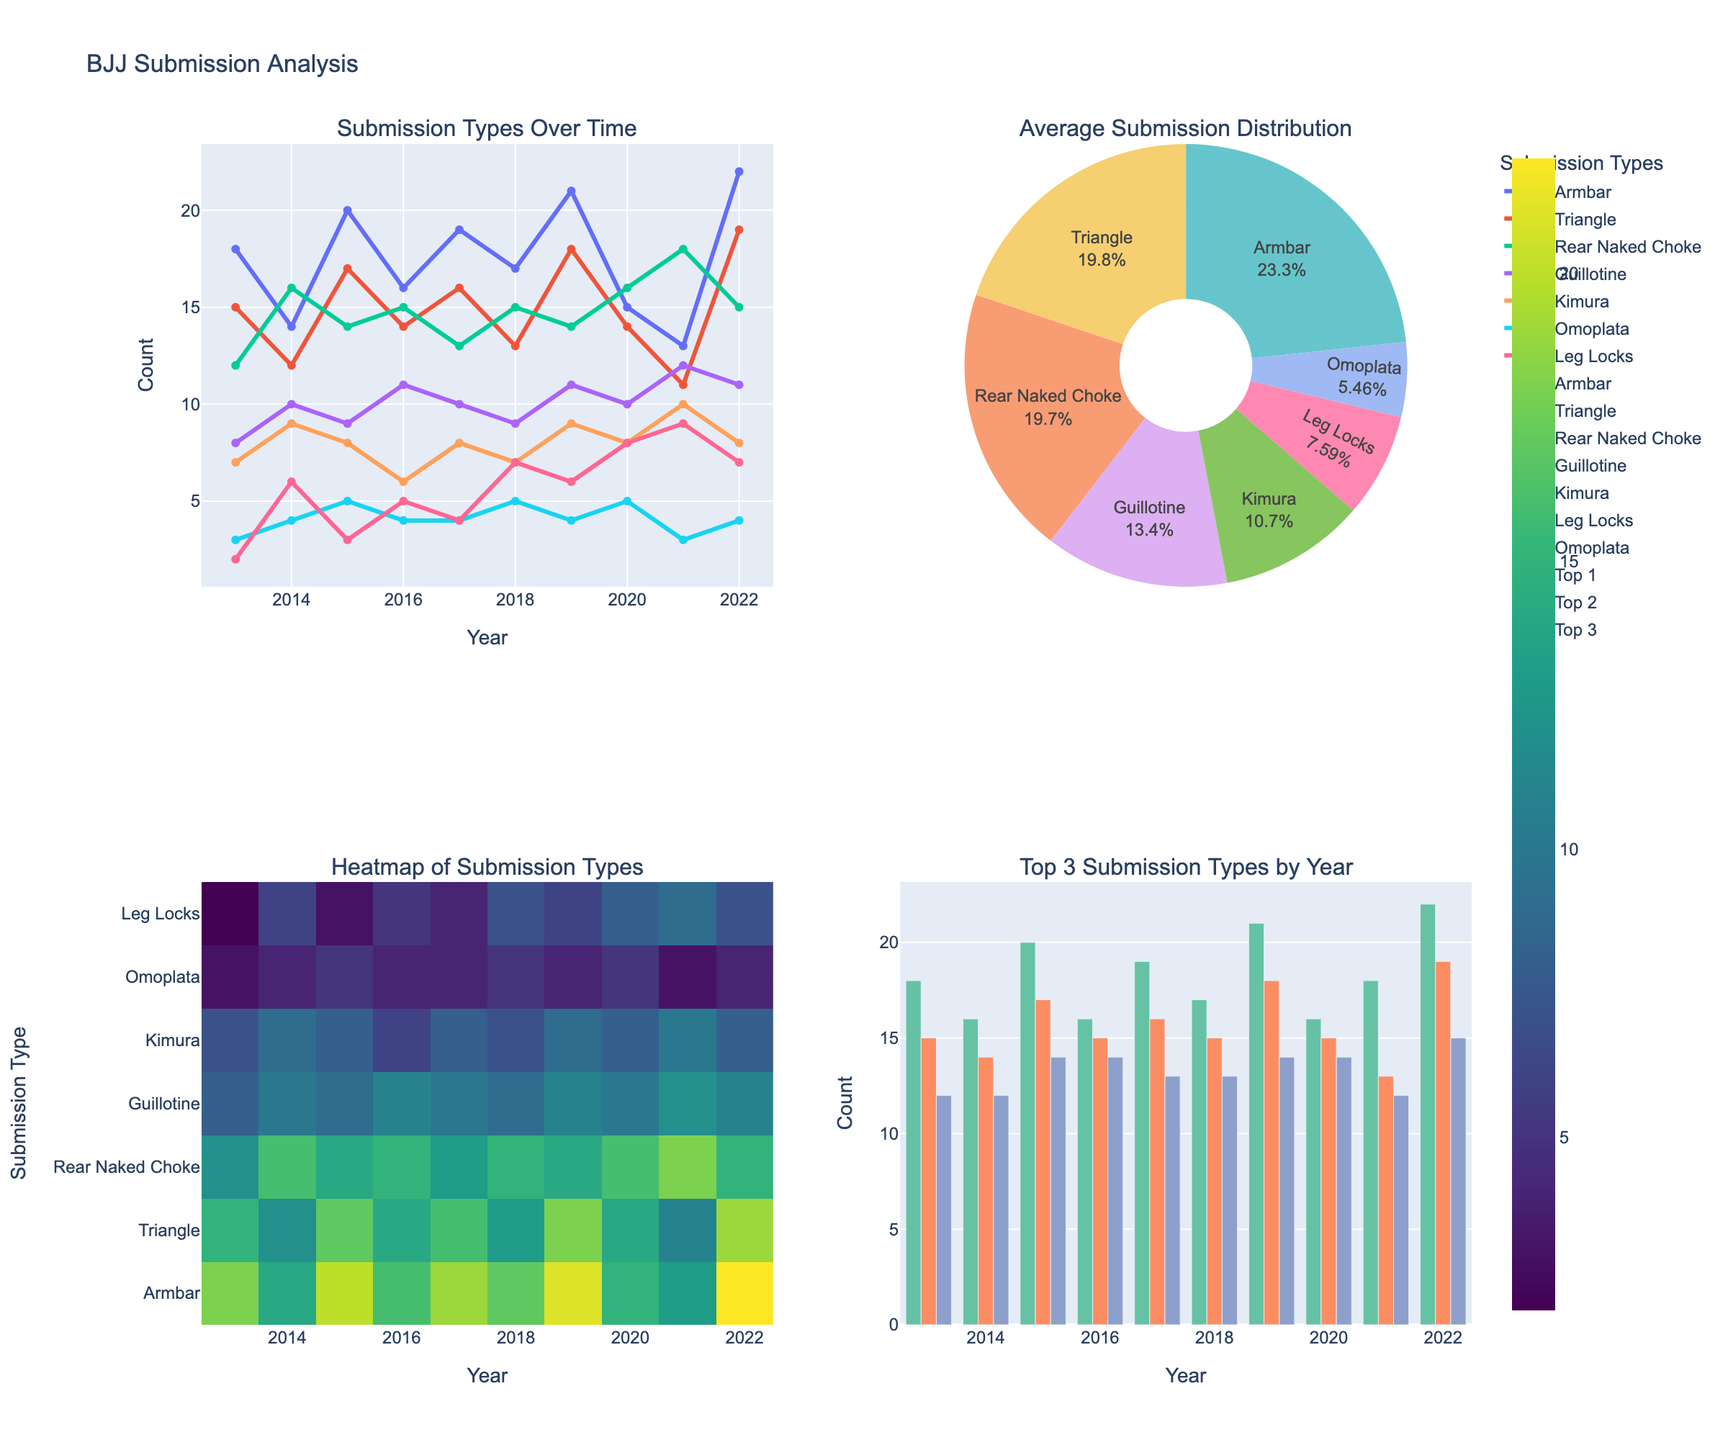What's the overall trend for submissions over the years? To determine the overall trend of each submission type over the years, observe the line plot in the "Submission Types Over Time" subplot. Generally, lines that are increasing indicate a rising trend, and those decreasing indicate a falling trend.
Answer: Mixed trends, with some increasing and some decreasing Which submission type has the highest average distribution over the last decade? Refer to the "Average Submission Distribution" pie chart. Find the submission type with the largest proportion of the pie.
Answer: Armbar How do Armbar and Rear Naked Choke submissions compare in 2022? Look at the "Top 3 Submission Types by Year" bar for 2022. Compare the heights of the bars for "Armbar" and "Rear Naked Choke."
Answer: Armbar is higher How many submission types are visualized in the heatmap? The heatmap subplot should show the number of rows representing each submission type. Count these rows.
Answer: Seven Did the number of Kimura submissions increase or decrease from 2013 to 2022? For Kimura, observe the line plot in the "Submission Types Over Time" subplot. Compare the data points for years 2013 and 2022.
Answer: Increase What are the three most frequent submission types in 2021 according to the bar chart? Refer to the "Top 3 Submission Types by Year" bar for 2021. Identify the submission types for the tallest three bars.
Answer: Rear Naked Choke, Guillotine, Kimura Which year had the lowest total submission counts across all types? Sense the color shades in the heatmap subplot, with lighter shades indicating lower values. Compare the column totals or use the line plot to sum up values for different years.
Answer: 2014 In which year did the Armbar submission type peak? In the "Submission Types Over Time" subplot, identify which year has the highest data point for the Armbar line.
Answer: 2022 Are Leg Locks becoming more common in recent years? Check the trend of Leg Locks line in the "Submission Types Over Time" subplot for recent years, specifically noting if the line is rising.
Answer: Yes 